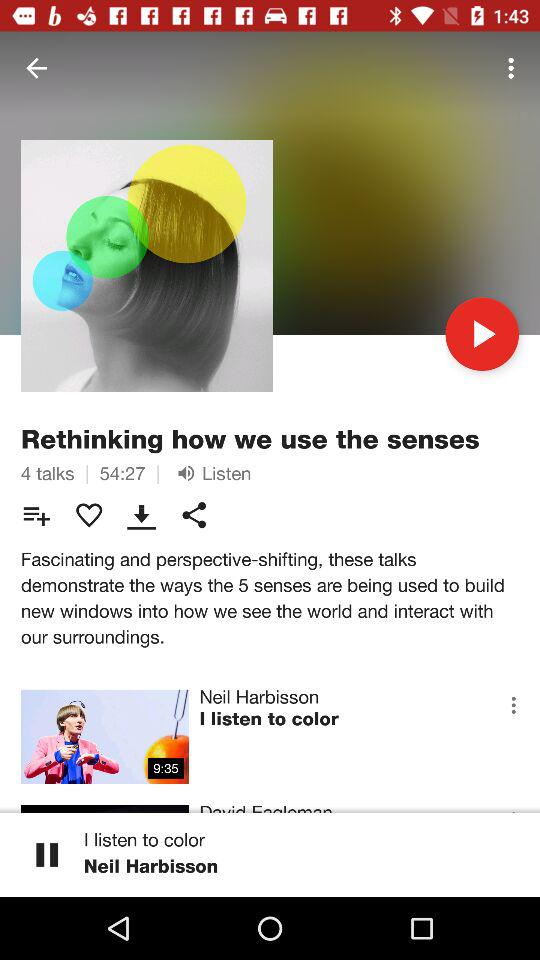Which song is playing? The song "I listen to color" is playing. 